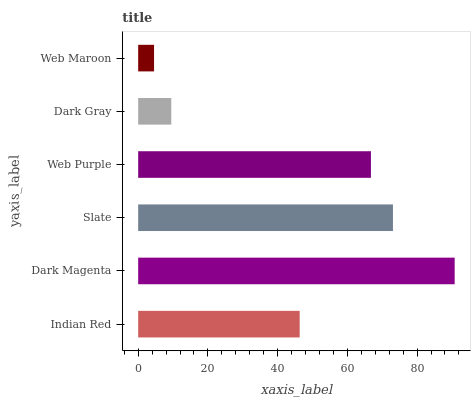Is Web Maroon the minimum?
Answer yes or no. Yes. Is Dark Magenta the maximum?
Answer yes or no. Yes. Is Slate the minimum?
Answer yes or no. No. Is Slate the maximum?
Answer yes or no. No. Is Dark Magenta greater than Slate?
Answer yes or no. Yes. Is Slate less than Dark Magenta?
Answer yes or no. Yes. Is Slate greater than Dark Magenta?
Answer yes or no. No. Is Dark Magenta less than Slate?
Answer yes or no. No. Is Web Purple the high median?
Answer yes or no. Yes. Is Indian Red the low median?
Answer yes or no. Yes. Is Indian Red the high median?
Answer yes or no. No. Is Dark Magenta the low median?
Answer yes or no. No. 